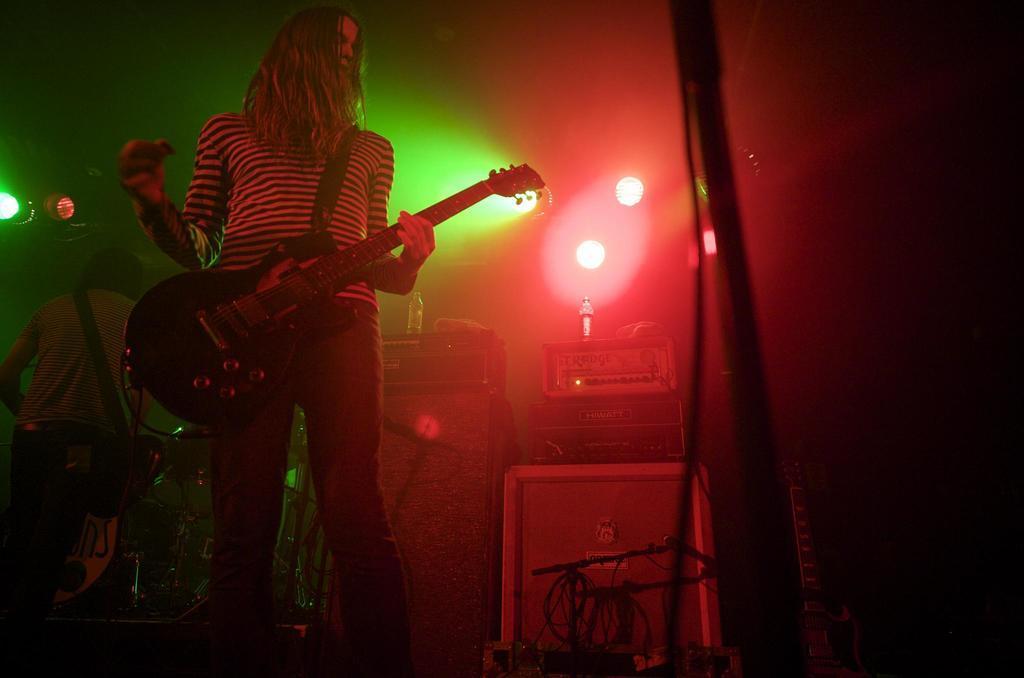Can you describe this image briefly? In this picture I can see there is a person holding a guitar and there is another person standing in the backdrop. There are lights attached to the ceiling. 